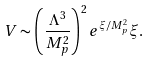<formula> <loc_0><loc_0><loc_500><loc_500>V \sim \left ( \frac { \Lambda ^ { 3 } } { M _ { p } ^ { 2 } } \right ) ^ { 2 } e ^ { \xi / M ^ { 2 } _ { p } } \xi .</formula> 